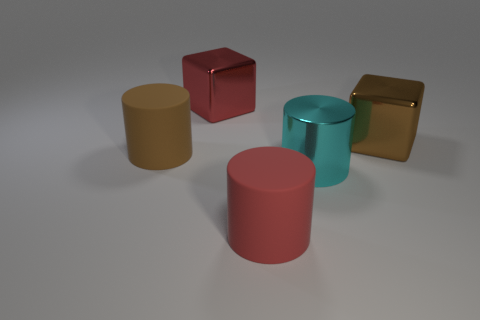Are there any other things that have the same size as the cyan cylinder?
Keep it short and to the point. Yes. There is a cyan metal thing; are there any cyan metallic objects right of it?
Provide a succinct answer. No. The big rubber cylinder that is right of the metal thing that is on the left side of the cyan metal thing to the right of the brown matte thing is what color?
Your answer should be very brief. Red. There is a cyan thing that is the same size as the red cylinder; what shape is it?
Provide a short and direct response. Cylinder. Are there more large red balls than red objects?
Give a very brief answer. No. Is there a metallic cube that is right of the cyan metallic cylinder that is in front of the big brown matte cylinder?
Your answer should be very brief. Yes. There is another big object that is the same shape as the red shiny object; what color is it?
Give a very brief answer. Brown. Is there anything else that has the same shape as the big cyan shiny thing?
Your response must be concise. Yes. There is another big block that is the same material as the red cube; what color is it?
Offer a very short reply. Brown. There is a matte thing in front of the big brown thing in front of the brown block; is there a big red metal object that is on the left side of it?
Give a very brief answer. Yes. 